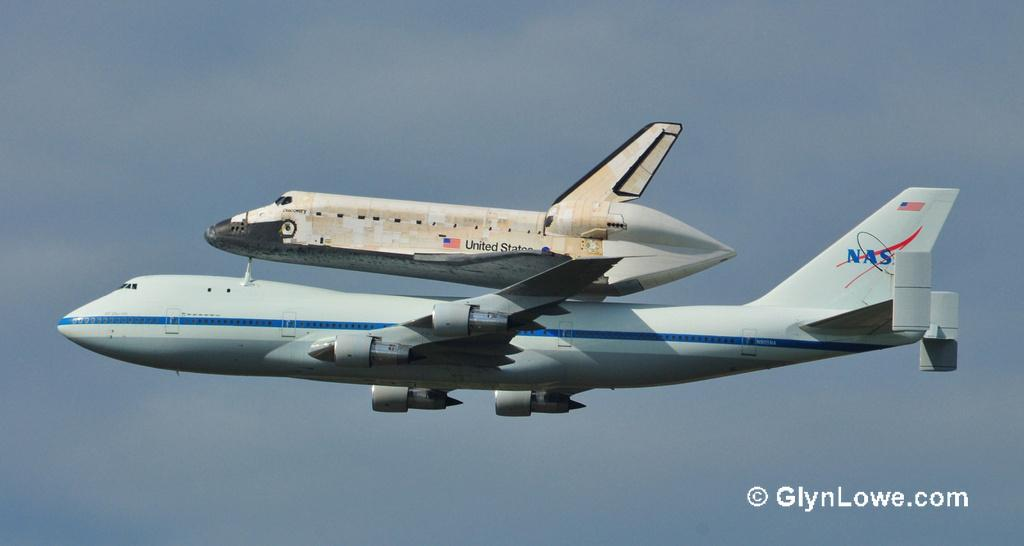Provide a one-sentence caption for the provided image. The US space shuttle is being carried by a NASA plane. 